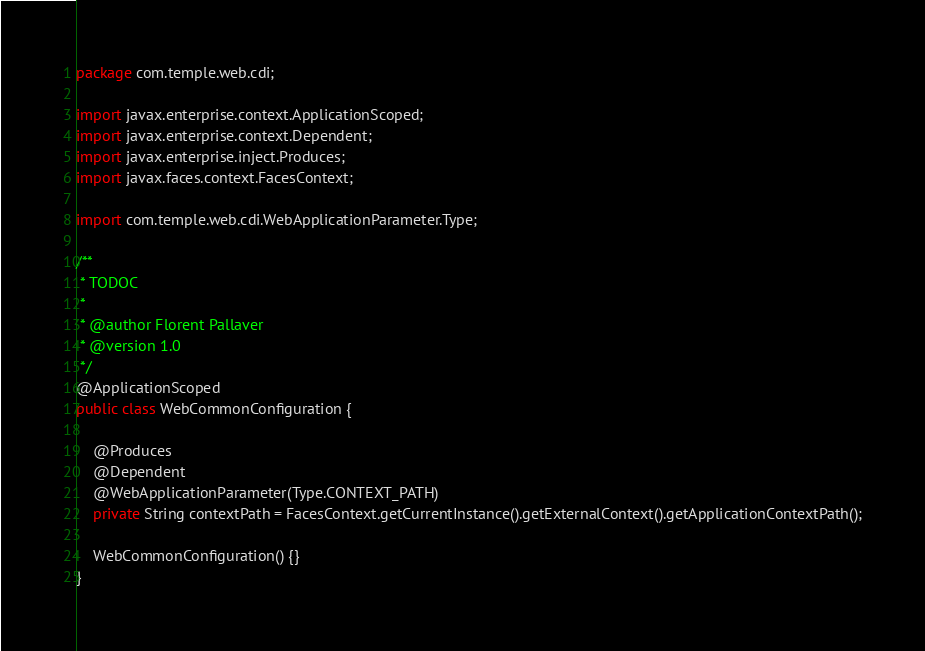<code> <loc_0><loc_0><loc_500><loc_500><_Java_>package com.temple.web.cdi;

import javax.enterprise.context.ApplicationScoped;
import javax.enterprise.context.Dependent;
import javax.enterprise.inject.Produces;
import javax.faces.context.FacesContext;

import com.temple.web.cdi.WebApplicationParameter.Type;

/**
 * TODOC
 * 
 * @author Florent Pallaver
 * @version 1.0
 */
@ApplicationScoped
public class WebCommonConfiguration {

	@Produces
	@Dependent
	@WebApplicationParameter(Type.CONTEXT_PATH)
	private String contextPath = FacesContext.getCurrentInstance().getExternalContext().getApplicationContextPath();

	WebCommonConfiguration() {}
}
</code> 